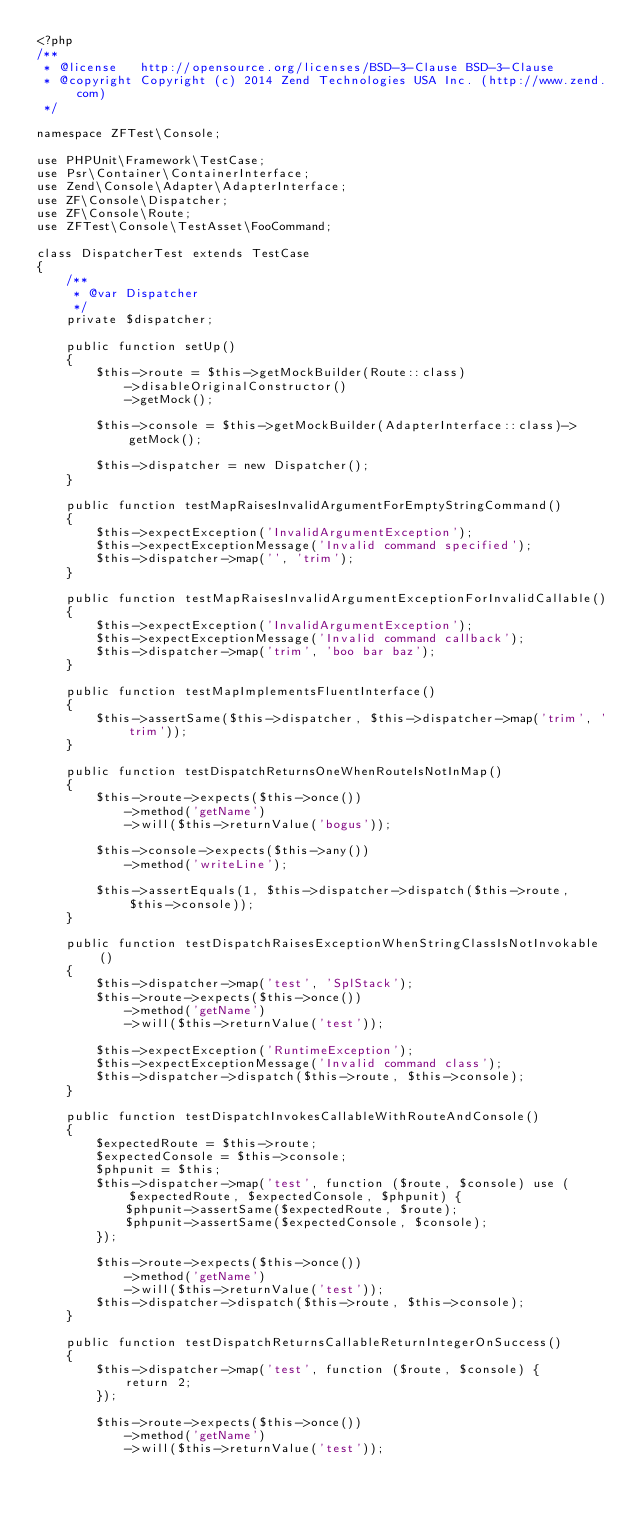Convert code to text. <code><loc_0><loc_0><loc_500><loc_500><_PHP_><?php
/**
 * @license   http://opensource.org/licenses/BSD-3-Clause BSD-3-Clause
 * @copyright Copyright (c) 2014 Zend Technologies USA Inc. (http://www.zend.com)
 */

namespace ZFTest\Console;

use PHPUnit\Framework\TestCase;
use Psr\Container\ContainerInterface;
use Zend\Console\Adapter\AdapterInterface;
use ZF\Console\Dispatcher;
use ZF\Console\Route;
use ZFTest\Console\TestAsset\FooCommand;

class DispatcherTest extends TestCase
{
    /**
     * @var Dispatcher
     */
    private $dispatcher;

    public function setUp()
    {
        $this->route = $this->getMockBuilder(Route::class)
            ->disableOriginalConstructor()
            ->getMock();

        $this->console = $this->getMockBuilder(AdapterInterface::class)->getMock();

        $this->dispatcher = new Dispatcher();
    }

    public function testMapRaisesInvalidArgumentForEmptyStringCommand()
    {
        $this->expectException('InvalidArgumentException');
        $this->expectExceptionMessage('Invalid command specified');
        $this->dispatcher->map('', 'trim');
    }

    public function testMapRaisesInvalidArgumentExceptionForInvalidCallable()
    {
        $this->expectException('InvalidArgumentException');
        $this->expectExceptionMessage('Invalid command callback');
        $this->dispatcher->map('trim', 'boo bar baz');
    }

    public function testMapImplementsFluentInterface()
    {
        $this->assertSame($this->dispatcher, $this->dispatcher->map('trim', 'trim'));
    }

    public function testDispatchReturnsOneWhenRouteIsNotInMap()
    {
        $this->route->expects($this->once())
            ->method('getName')
            ->will($this->returnValue('bogus'));

        $this->console->expects($this->any())
            ->method('writeLine');

        $this->assertEquals(1, $this->dispatcher->dispatch($this->route, $this->console));
    }

    public function testDispatchRaisesExceptionWhenStringClassIsNotInvokable()
    {
        $this->dispatcher->map('test', 'SplStack');
        $this->route->expects($this->once())
            ->method('getName')
            ->will($this->returnValue('test'));

        $this->expectException('RuntimeException');
        $this->expectExceptionMessage('Invalid command class');
        $this->dispatcher->dispatch($this->route, $this->console);
    }

    public function testDispatchInvokesCallableWithRouteAndConsole()
    {
        $expectedRoute = $this->route;
        $expectedConsole = $this->console;
        $phpunit = $this;
        $this->dispatcher->map('test', function ($route, $console) use ($expectedRoute, $expectedConsole, $phpunit) {
            $phpunit->assertSame($expectedRoute, $route);
            $phpunit->assertSame($expectedConsole, $console);
        });

        $this->route->expects($this->once())
            ->method('getName')
            ->will($this->returnValue('test'));
        $this->dispatcher->dispatch($this->route, $this->console);
    }

    public function testDispatchReturnsCallableReturnIntegerOnSuccess()
    {
        $this->dispatcher->map('test', function ($route, $console) {
            return 2;
        });

        $this->route->expects($this->once())
            ->method('getName')
            ->will($this->returnValue('test'));</code> 